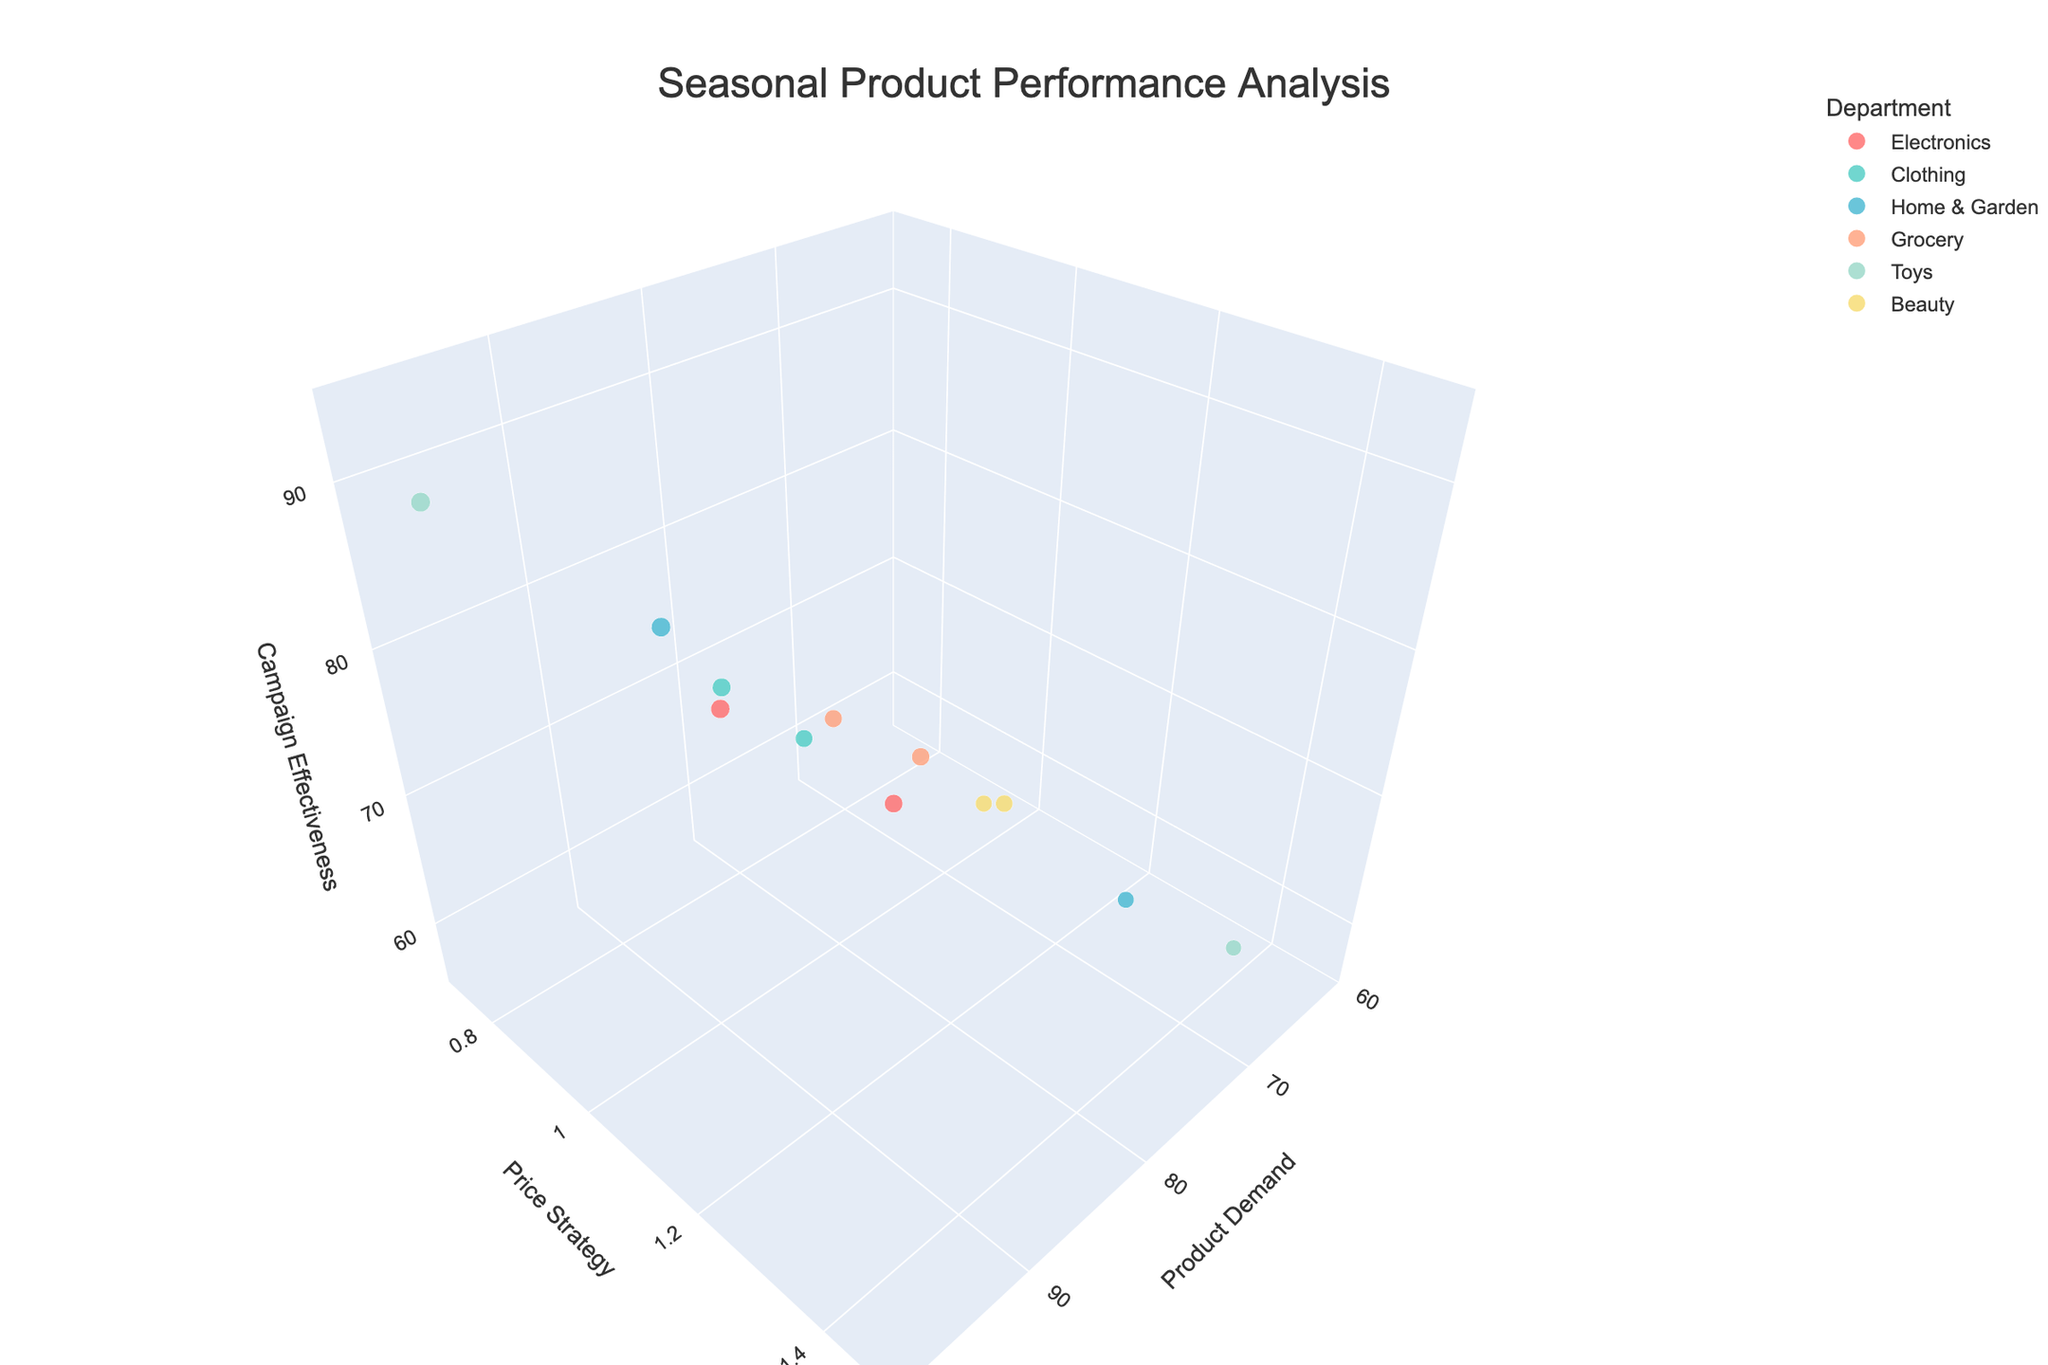What is the title of the figure? The title of the figure is found at the top of the chart in a large font.
Answer: Seasonal Product Performance Analysis Which department has the highest campaign effectiveness in winter? To find the highest campaign effectiveness, look for the highest z-coordinate (Campaign Effectiveness) among the points labeled with 'Winter' in the hover data. The 'Toys' department has a campaign effectiveness of 90 in winter.
Answer: Toys How does the product demand of Home & Garden in summer compare to Clothing in fall? Find the product demand values for Home & Garden in summer and Clothing in fall by hovering over the respective points. Home & Garden in summer has a demand of 95, and Clothing in fall has a demand of 88. Therefore, Home & Garden in summer has a higher demand than Clothing in fall.
Answer: Home & Garden in summer has a higher demand Which department in spring has a higher campaign effectiveness, Beauty or Home & Garden? To compare, look at the z-coordinates for Beauty and Home & Garden in spring. Beauty has a campaign effectiveness of 65, and Home & Garden has a campaign effectiveness of 62. Thus, Beauty has a higher campaign effectiveness.
Answer: Beauty What is the average price strategy of all departments in fall? Find price strategy values for all points labeled 'Fall' (Clothing, Grocery, and Beauty with price strategies of 1.0, 1.2, and 1.2 respectively). Calculate the average: (1.0 + 1.2 + 1.2) / 3 = 1.13.
Answer: 1.13 Which season has the widest range of product demand? By observing the x-axis range among points grouped by season: Winter (80 to 98), Spring (70 to 78), Summer (65 to 95), Fall (76 to 88). Winter's range is 18, Spring's is 8, Summer's is 30, Fall's is 12. The widest range is in summer.
Answer: Summer Between Electronics and Toys, which has a lower price strategy in summer? Find the points for Electronics and Toys in summer and compare their y-coordinates. Electronics has a price strategy of 1.2, and Toys have 1.4. Thus, Electronics has a lower price strategy.
Answer: Electronics What is the total campaign effectiveness for all departments in spring? Locate the z-coordinates for all points labeled 'Spring' (Clothing, Home & Garden, and Beauty with effectiveness of 68, 62, and 65 respectively). Sum them: 68 + 62 + 65 = 195.
Answer: 195 